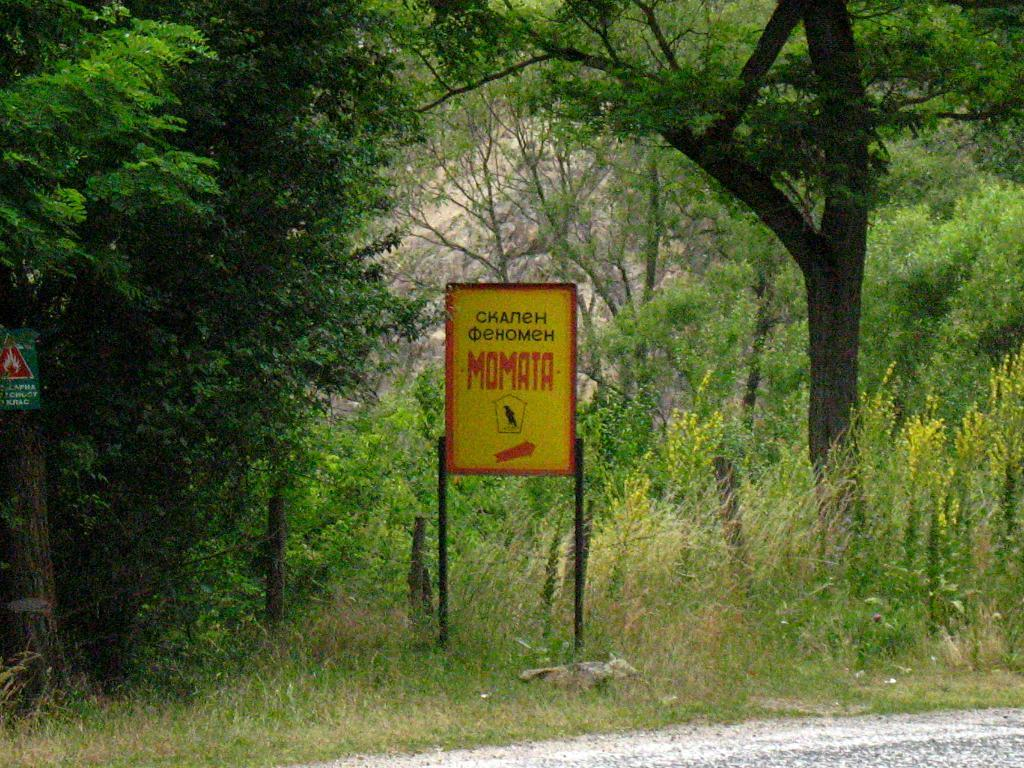<image>
Offer a succinct explanation of the picture presented. The sign for Momata is displayed in yellow and red colors. 